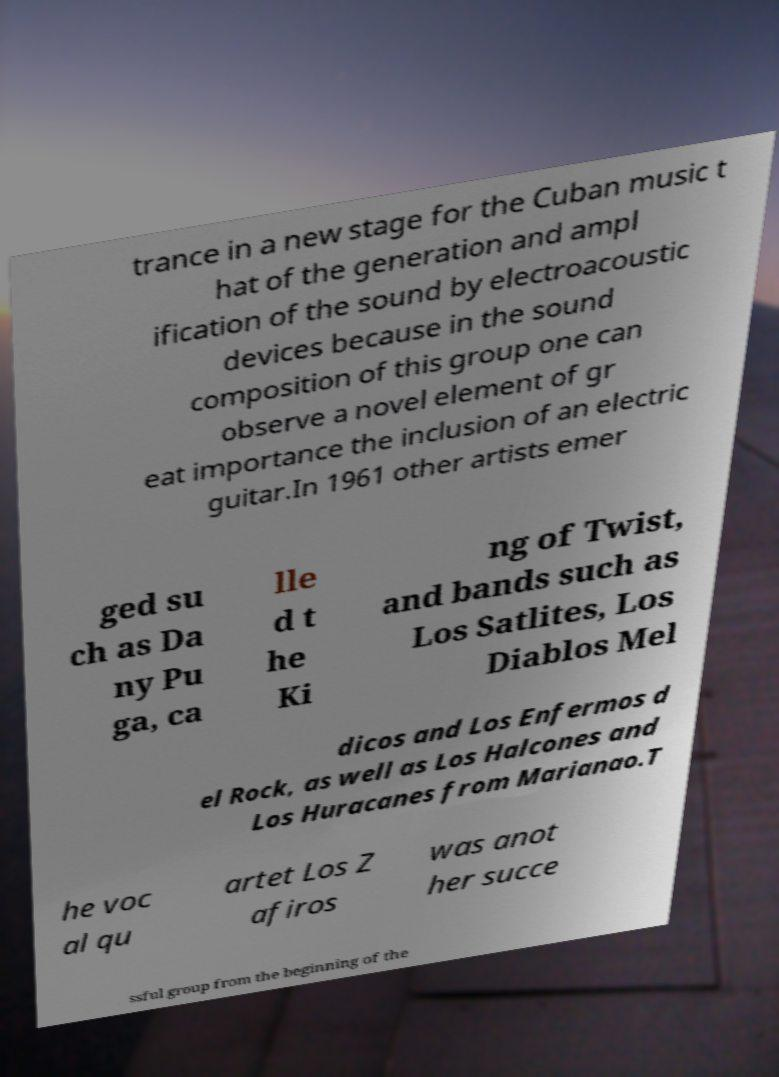I need the written content from this picture converted into text. Can you do that? trance in a new stage for the Cuban music t hat of the generation and ampl ification of the sound by electroacoustic devices because in the sound composition of this group one can observe a novel element of gr eat importance the inclusion of an electric guitar.In 1961 other artists emer ged su ch as Da ny Pu ga, ca lle d t he Ki ng of Twist, and bands such as Los Satlites, Los Diablos Mel dicos and Los Enfermos d el Rock, as well as Los Halcones and Los Huracanes from Marianao.T he voc al qu artet Los Z afiros was anot her succe ssful group from the beginning of the 